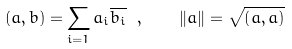Convert formula to latex. <formula><loc_0><loc_0><loc_500><loc_500>\left ( { a } , { b } \right ) = \sum _ { i = 1 } a _ { i } \overline { b _ { i } } \ , \quad \| { a } \| = \sqrt { \left ( { a } , { a } \right ) }</formula> 